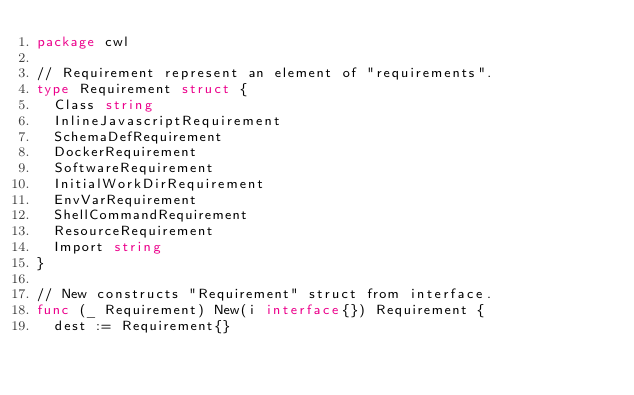Convert code to text. <code><loc_0><loc_0><loc_500><loc_500><_Go_>package cwl

// Requirement represent an element of "requirements".
type Requirement struct {
	Class string
	InlineJavascriptRequirement
	SchemaDefRequirement
	DockerRequirement
	SoftwareRequirement
	InitialWorkDirRequirement
	EnvVarRequirement
	ShellCommandRequirement
	ResourceRequirement
	Import string
}

// New constructs "Requirement" struct from interface.
func (_ Requirement) New(i interface{}) Requirement {
	dest := Requirement{}</code> 